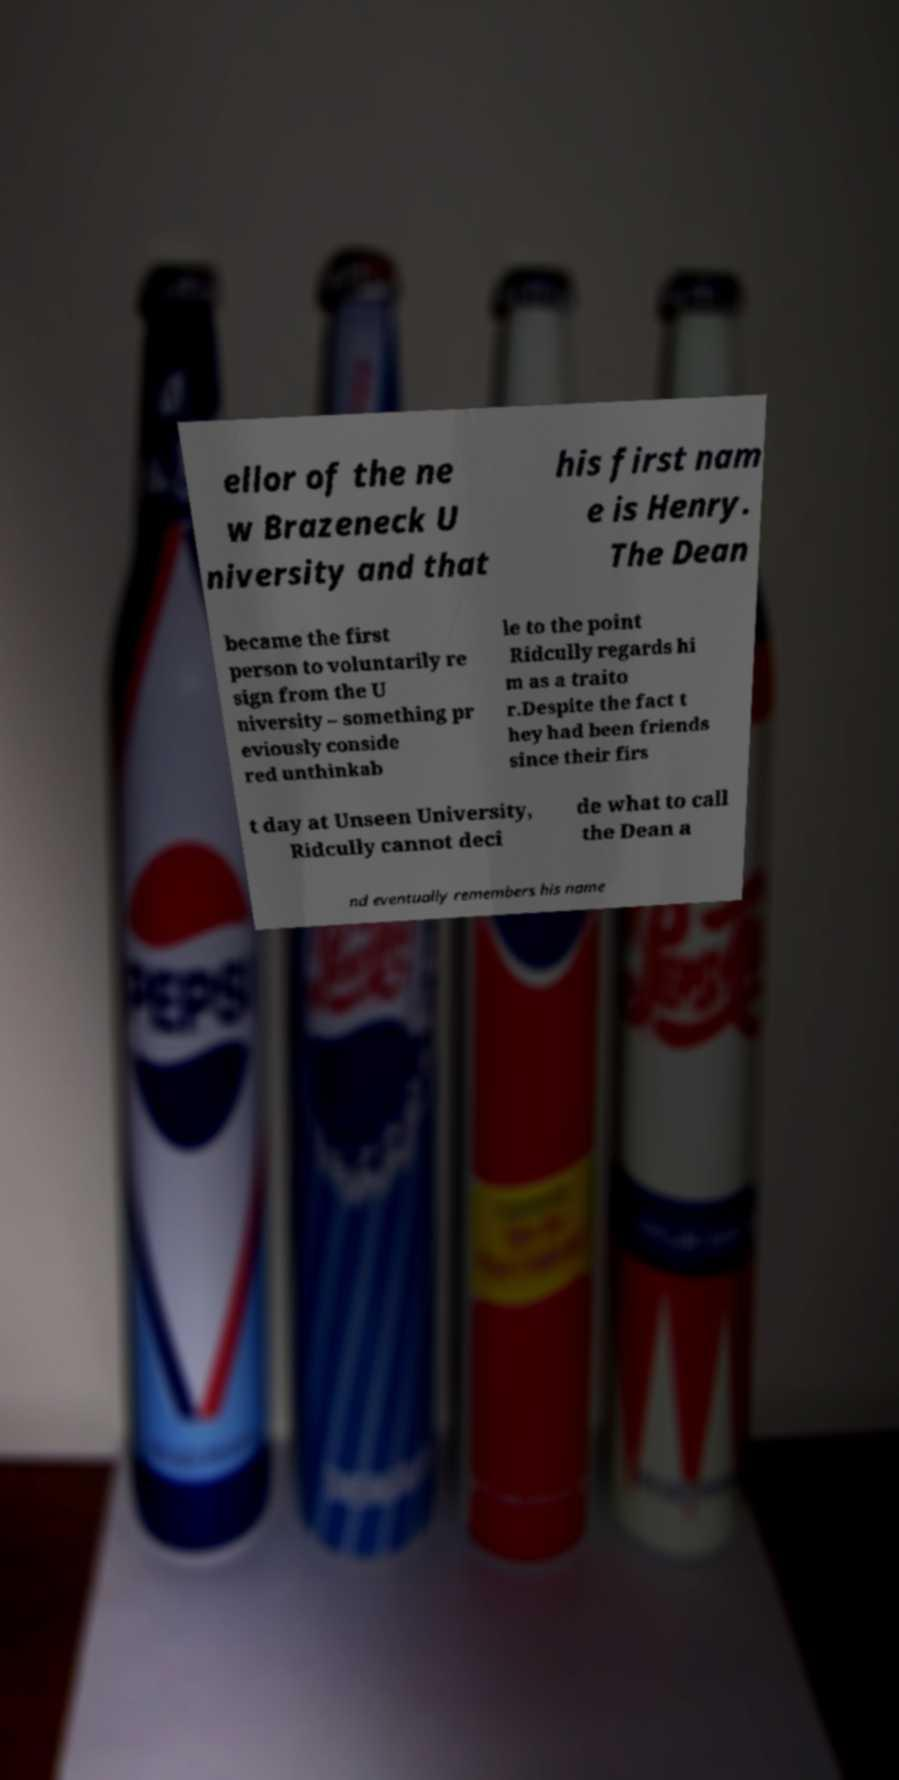What messages or text are displayed in this image? I need them in a readable, typed format. ellor of the ne w Brazeneck U niversity and that his first nam e is Henry. The Dean became the first person to voluntarily re sign from the U niversity – something pr eviously conside red unthinkab le to the point Ridcully regards hi m as a traito r.Despite the fact t hey had been friends since their firs t day at Unseen University, Ridcully cannot deci de what to call the Dean a nd eventually remembers his name 